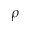<formula> <loc_0><loc_0><loc_500><loc_500>\rho</formula> 